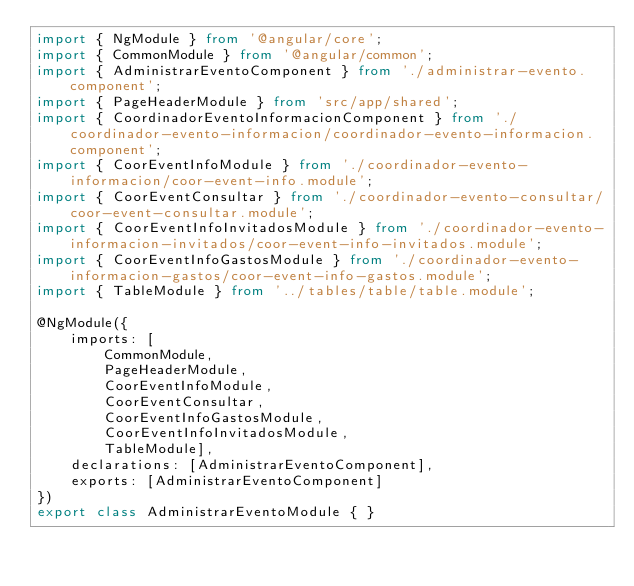Convert code to text. <code><loc_0><loc_0><loc_500><loc_500><_TypeScript_>import { NgModule } from '@angular/core';
import { CommonModule } from '@angular/common';
import { AdministrarEventoComponent } from './administrar-evento.component';
import { PageHeaderModule } from 'src/app/shared';
import { CoordinadorEventoInformacionComponent } from './coordinador-evento-informacion/coordinador-evento-informacion.component';
import { CoorEventInfoModule } from './coordinador-evento-informacion/coor-event-info.module';
import { CoorEventConsultar } from './coordinador-evento-consultar/coor-event-consultar.module';
import { CoorEventInfoInvitadosModule } from './coordinador-evento-informacion-invitados/coor-event-info-invitados.module';
import { CoorEventInfoGastosModule } from './coordinador-evento-informacion-gastos/coor-event-info-gastos.module';
import { TableModule } from '../tables/table/table.module';

@NgModule({
    imports: [
        CommonModule,
        PageHeaderModule,
        CoorEventInfoModule,
        CoorEventConsultar,
        CoorEventInfoGastosModule,
        CoorEventInfoInvitadosModule,
        TableModule],
    declarations: [AdministrarEventoComponent],
    exports: [AdministrarEventoComponent]
})
export class AdministrarEventoModule { }
</code> 